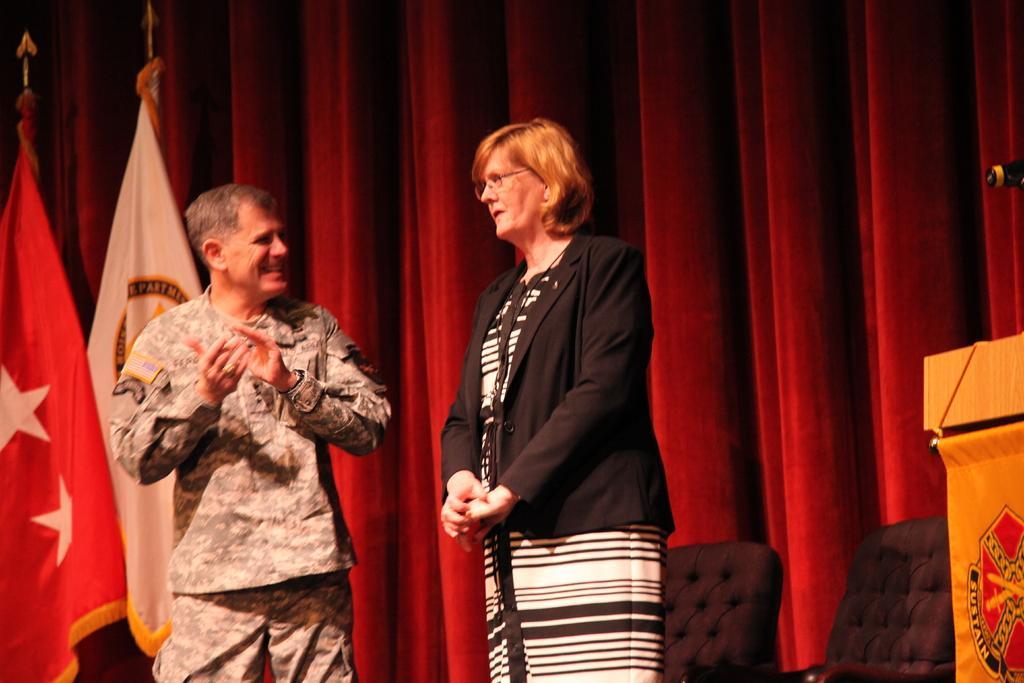Could you give a brief overview of what you see in this image? In this image I can see a woman wearing white and black dress and black blazer is standing and a man wearing uniform is standing. In the background I can see few flags, the red colored curtain, few chairs and the podium. 